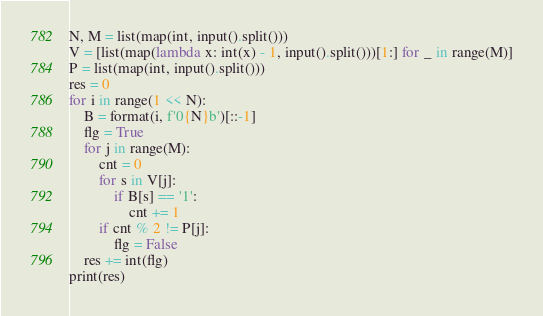Convert code to text. <code><loc_0><loc_0><loc_500><loc_500><_Python_>N, M = list(map(int, input().split()))
V = [list(map(lambda x: int(x) - 1, input().split()))[1:] for _ in range(M)]
P = list(map(int, input().split()))
res = 0
for i in range(1 << N):
    B = format(i, f'0{N}b')[::-1]
    flg = True
    for j in range(M):
        cnt = 0
        for s in V[j]:
            if B[s] == '1':
                cnt += 1
        if cnt % 2 != P[j]:
            flg = False
    res += int(flg)
print(res)
</code> 